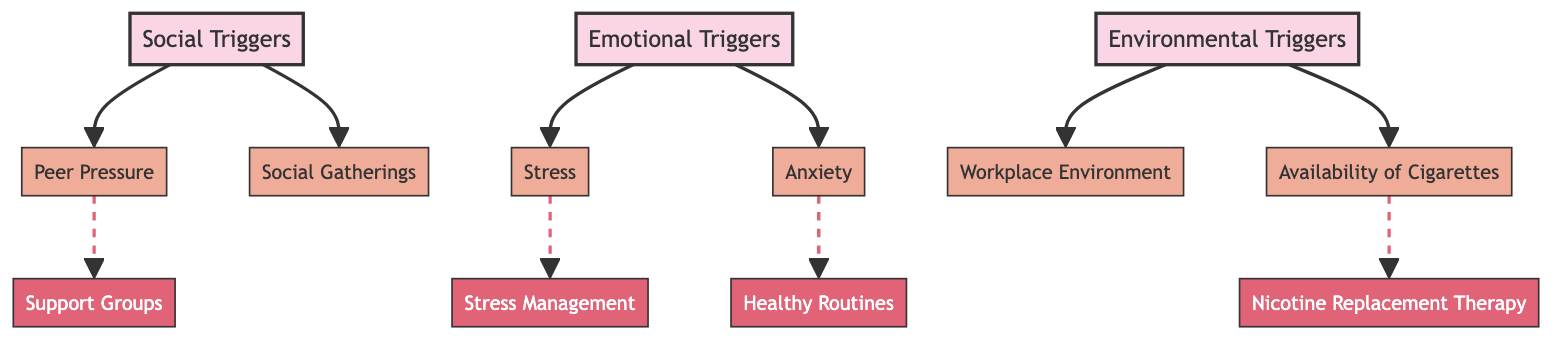What are the three main categories of triggers for smoking relapse? The diagram displays three main categories: Social Triggers, Emotional Triggers, and Environmental Triggers. They are the primary nodes and represent the key areas where triggers may arise.
Answer: Social Triggers, Emotional Triggers, Environmental Triggers How many sub-nodes are connected to the Social Triggers node? From the diagram, under the Social Triggers node, there are two sub-nodes: Peer Pressure and Social Gatherings. Thus, there are a total of two sub-nodes connected to this node.
Answer: 2 Which strategy is associated with managing anxiety? According to the diagram, Anxiety under Emotional Triggers is linked to the Healthy Routines strategy, which helps address the issue directly.
Answer: Healthy Routines What is the relationship between Peer Pressure and Support Groups? The diagram indicates that Peer Pressure is a social trigger leading to the strategy of Support Groups as a means to cope with or mitigate its effects, showing a direct association between the two.
Answer: Peer Pressure leads to Support Groups What are the two environmental triggers shown in the diagram? The diagram identifies two environmental triggers: Workplace Environment and Availability of Cigarettes. These are the relevant sub-nodes connected to Environmental Triggers.
Answer: Workplace Environment, Availability of Cigarettes How many total strategies are proposed in the diagram? In total, the diagram presents four strategies for overcoming triggers: Stress Management, Support Groups, Healthy Routines, and Nicotine Replacement Therapy, thus making the total four.
Answer: 4 What type of relationship is indicated between Stress and Stress Management? The diagram shows a dashed line from Stress to Stress Management, which represents a secondary relationship implying that Stress Management is a suggested strategy for overcoming the stress trigger.
Answer: Secondary relationship What color distinguishes the strategy nodes from the main nodes? The strategy nodes in the diagram are colored differently than the main nodes; they have a fill color of #e06377, which is distinct from the main nodes’ color, allowing for easy identification.
Answer: #e06377 